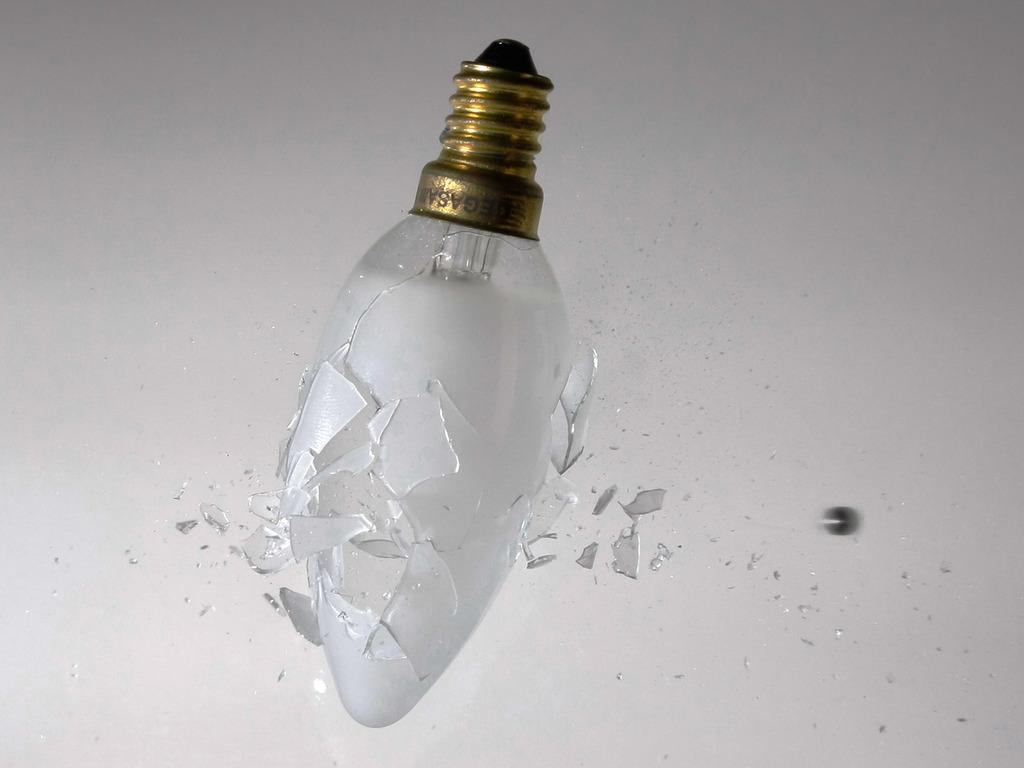What object is in the foreground of the image? There is a broken bulb in the foreground of the image. Can you describe the position of the bulb in the image? The bulb is in the air. What color is the background of the image? The background of the image is white. What type of tub can be seen in the image? There is no tub present in the image. Is there a camera visible in the image? There is no camera present in the image. Can you see a stream in the background of the image? There is no stream present in the image. 